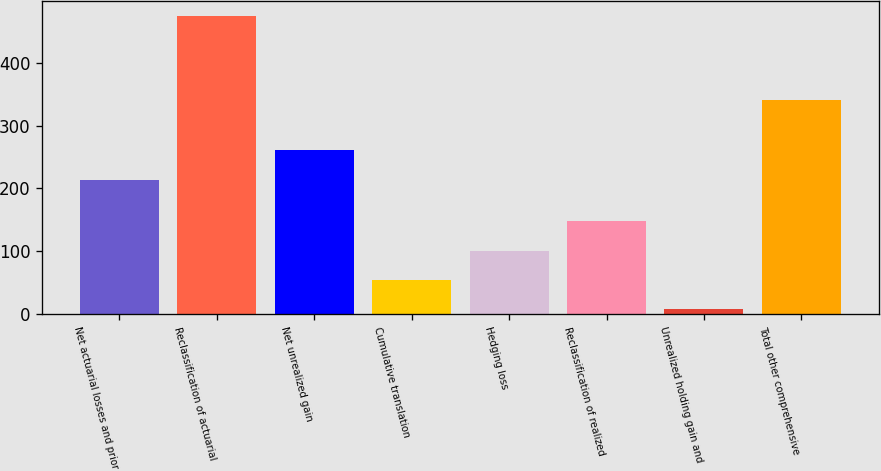<chart> <loc_0><loc_0><loc_500><loc_500><bar_chart><fcel>Net actuarial losses and prior<fcel>Reclassification of actuarial<fcel>Net unrealized gain<fcel>Cumulative translation<fcel>Hedging loss<fcel>Reclassification of realized<fcel>Unrealized holding gain and<fcel>Total other comprehensive<nl><fcel>213<fcel>474<fcel>261<fcel>54.6<fcel>101.2<fcel>147.8<fcel>8<fcel>341<nl></chart> 